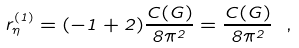Convert formula to latex. <formula><loc_0><loc_0><loc_500><loc_500>r ^ { ( 1 ) } _ { \eta } = ( - 1 + 2 ) \frac { C ( G ) } { 8 \pi ^ { 2 } } = \frac { C ( G ) } { 8 \pi ^ { 2 } } \ ,</formula> 